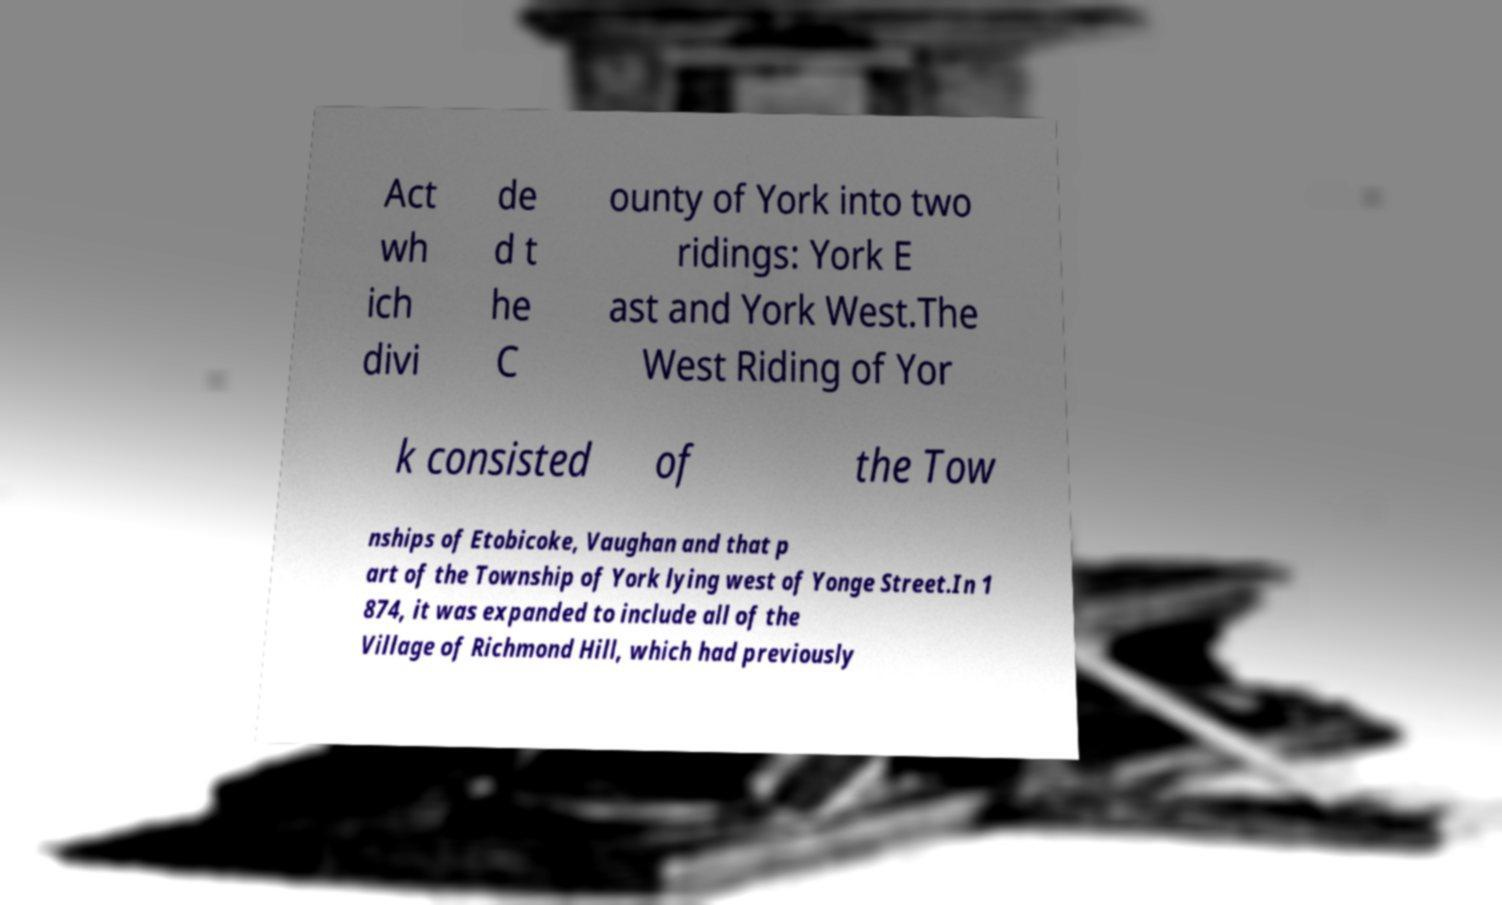Can you accurately transcribe the text from the provided image for me? Act wh ich divi de d t he C ounty of York into two ridings: York E ast and York West.The West Riding of Yor k consisted of the Tow nships of Etobicoke, Vaughan and that p art of the Township of York lying west of Yonge Street.In 1 874, it was expanded to include all of the Village of Richmond Hill, which had previously 